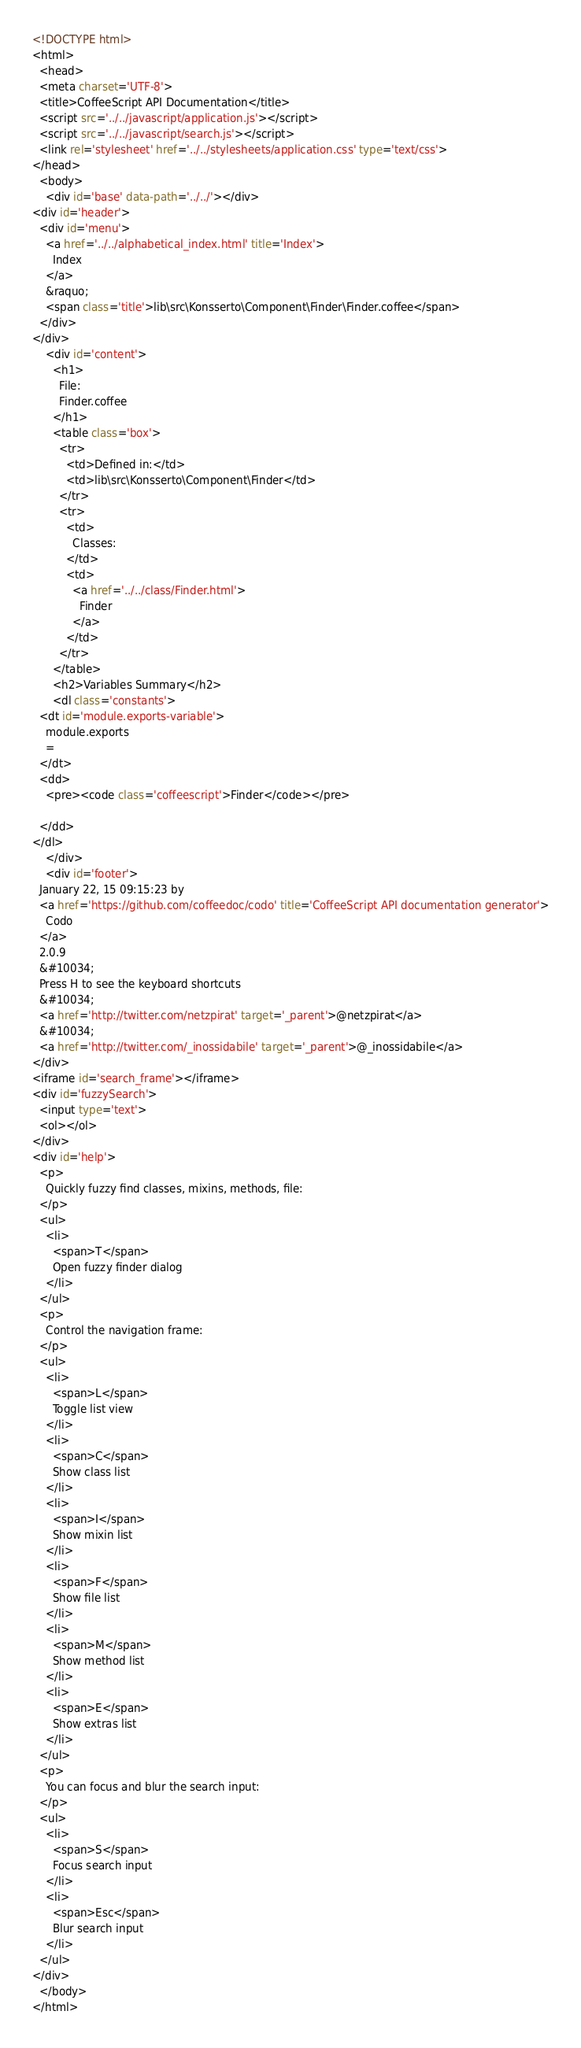Convert code to text. <code><loc_0><loc_0><loc_500><loc_500><_HTML_><!DOCTYPE html>
<html>
  <head>
  <meta charset='UTF-8'>
  <title>CoffeeScript API Documentation</title>
  <script src='../../javascript/application.js'></script>
  <script src='../../javascript/search.js'></script>
  <link rel='stylesheet' href='../../stylesheets/application.css' type='text/css'>
</head>
  <body>
    <div id='base' data-path='../../'></div>
<div id='header'>
  <div id='menu'>
    <a href='../../alphabetical_index.html' title='Index'>
      Index
    </a>
    &raquo;
    <span class='title'>lib\src\Konsserto\Component\Finder\Finder.coffee</span>
  </div>
</div>
    <div id='content'>
      <h1>
        File:
        Finder.coffee
      </h1>
      <table class='box'>
        <tr>
          <td>Defined in:</td>
          <td>lib\src\Konsserto\Component\Finder</td>
        </tr>
        <tr>
          <td>
            Classes:
          </td>
          <td>
            <a href='../../class/Finder.html'>
              Finder
            </a>
          </td>
        </tr>
      </table>
      <h2>Variables Summary</h2>
      <dl class='constants'>
  <dt id='module.exports-variable'>
    module.exports
    =
  </dt>
  <dd>
    <pre><code class='coffeescript'>Finder</code></pre>
    
  </dd>
</dl>
    </div>
    <div id='footer'>
  January 22, 15 09:15:23 by
  <a href='https://github.com/coffeedoc/codo' title='CoffeeScript API documentation generator'>
    Codo
  </a>
  2.0.9
  &#10034;
  Press H to see the keyboard shortcuts
  &#10034;
  <a href='http://twitter.com/netzpirat' target='_parent'>@netzpirat</a>
  &#10034;
  <a href='http://twitter.com/_inossidabile' target='_parent'>@_inossidabile</a>
</div>
<iframe id='search_frame'></iframe>
<div id='fuzzySearch'>
  <input type='text'>
  <ol></ol>
</div>
<div id='help'>
  <p>
    Quickly fuzzy find classes, mixins, methods, file:
  </p>
  <ul>
    <li>
      <span>T</span>
      Open fuzzy finder dialog
    </li>
  </ul>
  <p>
    Control the navigation frame:
  </p>
  <ul>
    <li>
      <span>L</span>
      Toggle list view
    </li>
    <li>
      <span>C</span>
      Show class list
    </li>
    <li>
      <span>I</span>
      Show mixin list
    </li>
    <li>
      <span>F</span>
      Show file list
    </li>
    <li>
      <span>M</span>
      Show method list
    </li>
    <li>
      <span>E</span>
      Show extras list
    </li>
  </ul>
  <p>
    You can focus and blur the search input:
  </p>
  <ul>
    <li>
      <span>S</span>
      Focus search input
    </li>
    <li>
      <span>Esc</span>
      Blur search input
    </li>
  </ul>
</div>
  </body>
</html></code> 